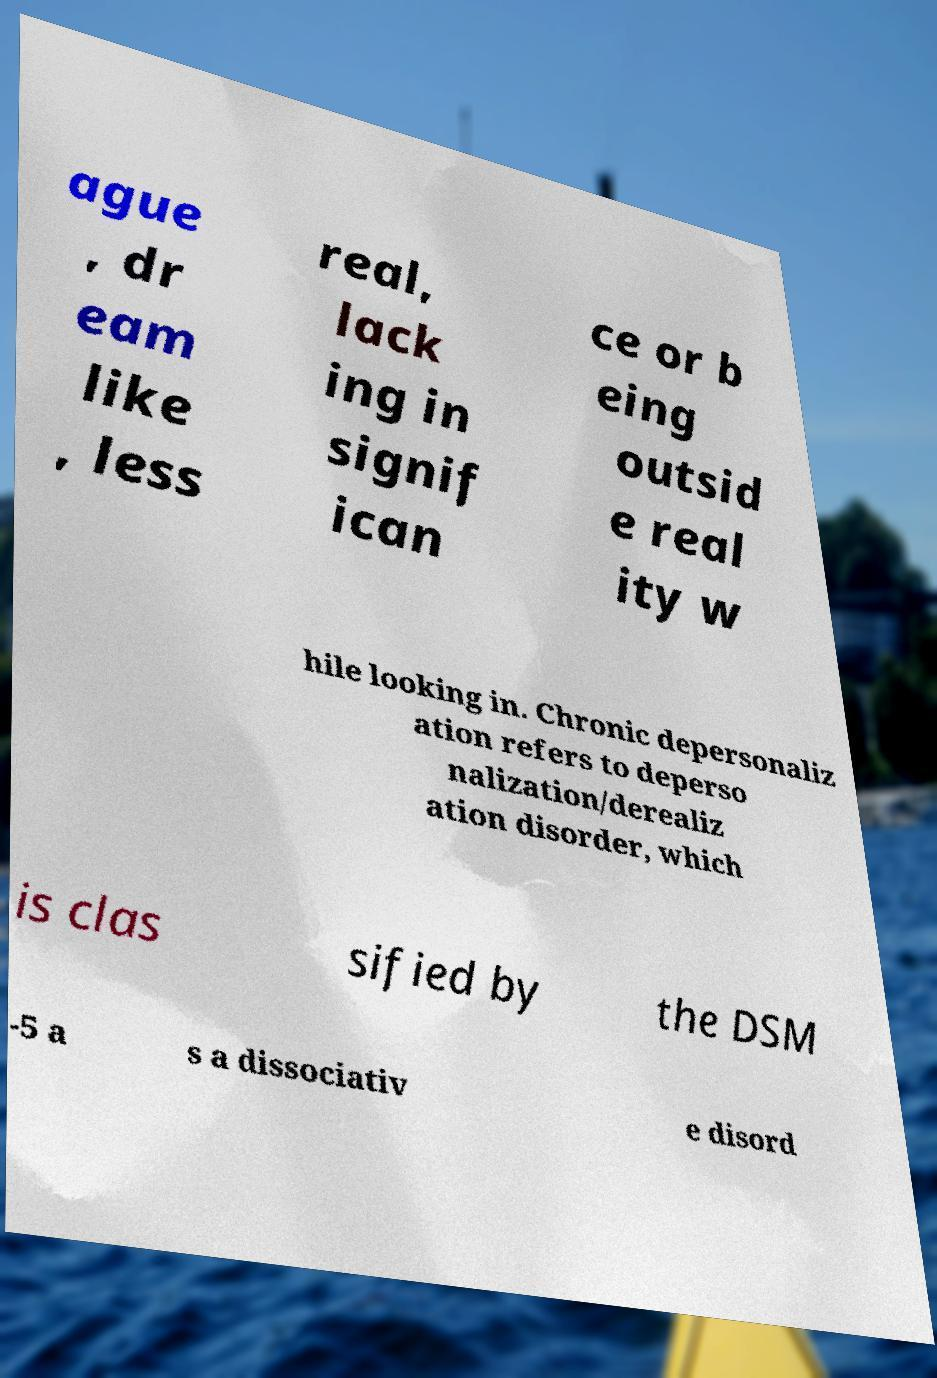Could you assist in decoding the text presented in this image and type it out clearly? ague , dr eam like , less real, lack ing in signif ican ce or b eing outsid e real ity w hile looking in. Chronic depersonaliz ation refers to deperso nalization/derealiz ation disorder, which is clas sified by the DSM -5 a s a dissociativ e disord 